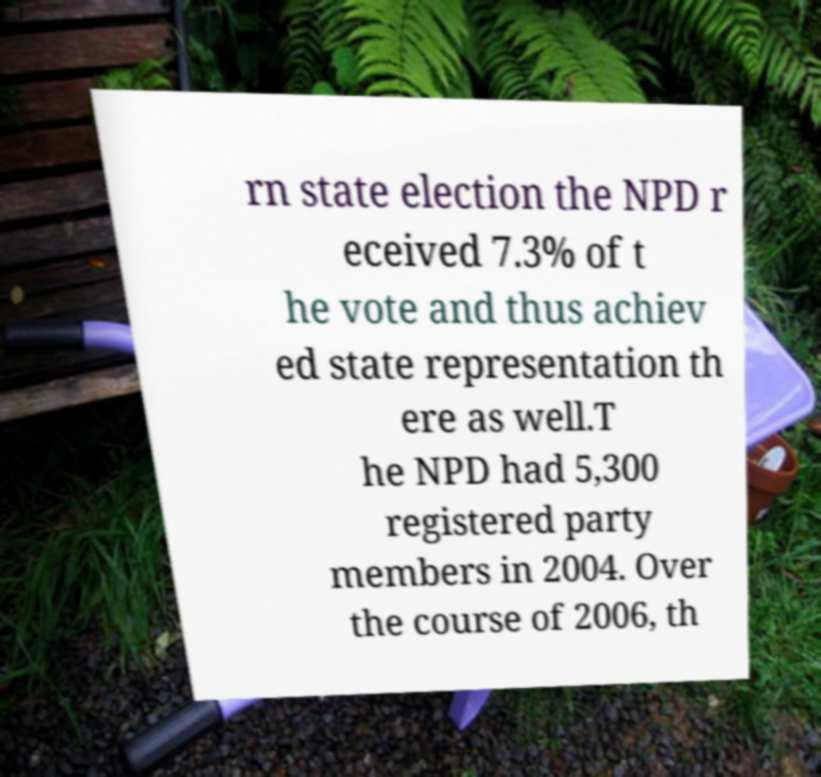Please read and relay the text visible in this image. What does it say? rn state election the NPD r eceived 7.3% of t he vote and thus achiev ed state representation th ere as well.T he NPD had 5,300 registered party members in 2004. Over the course of 2006, th 